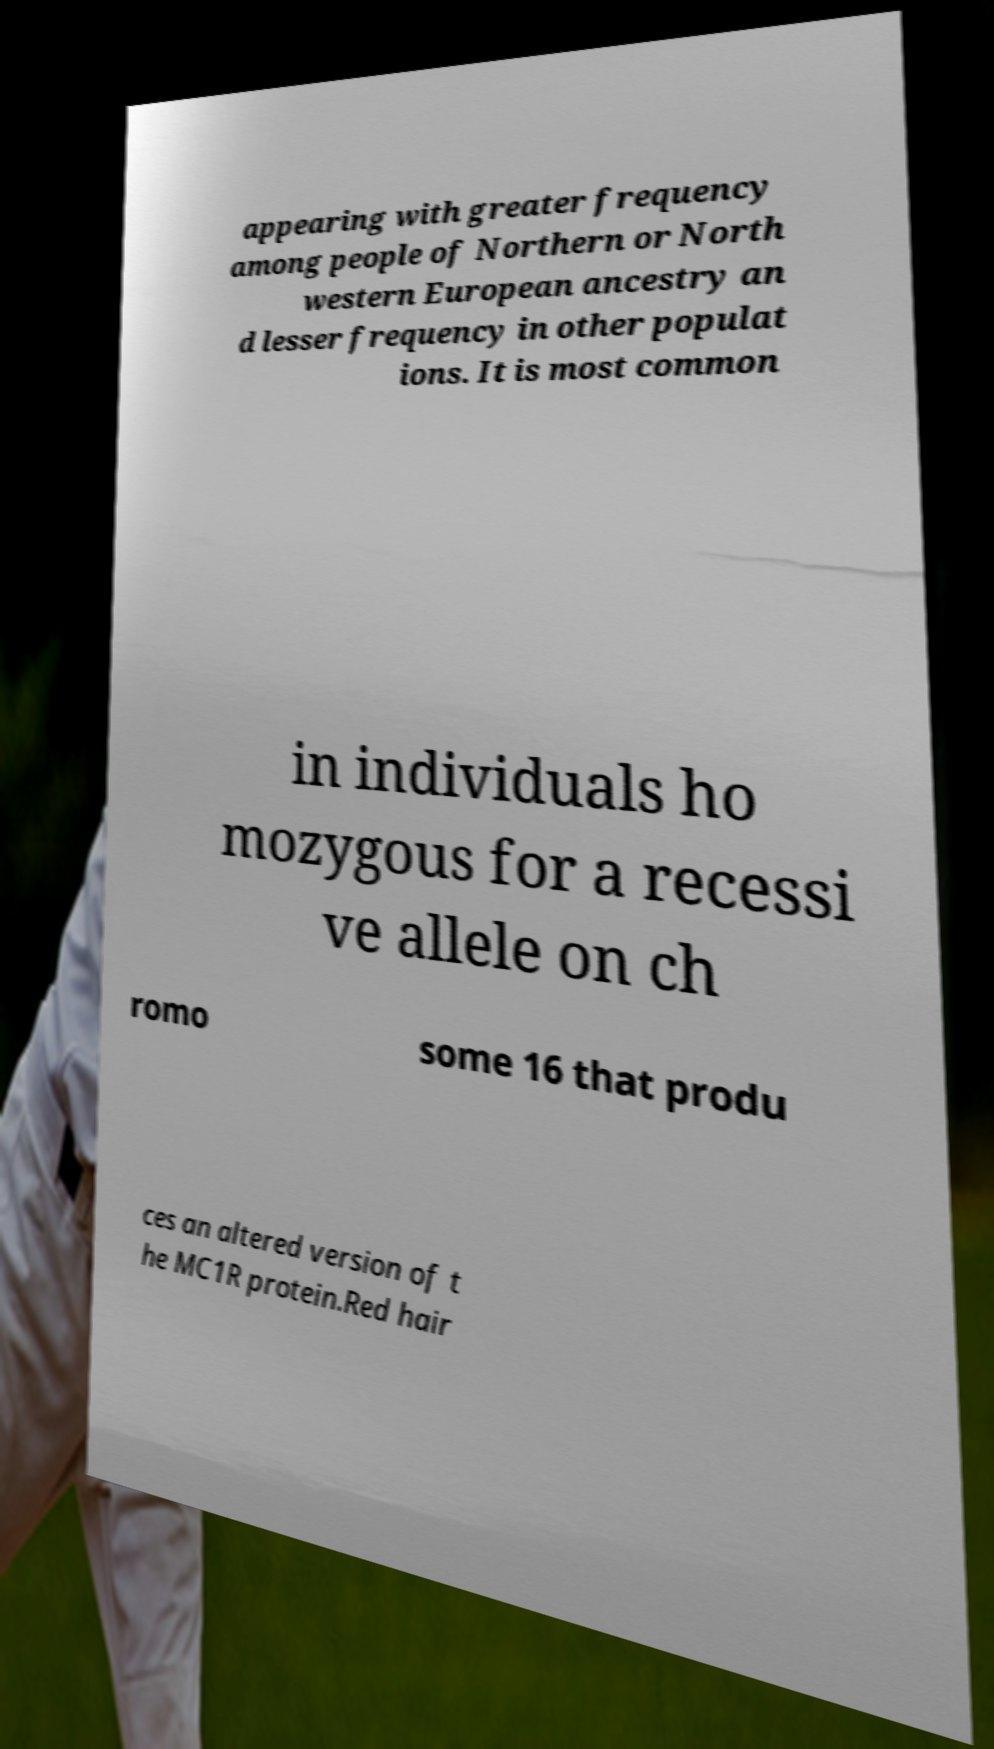Please identify and transcribe the text found in this image. appearing with greater frequency among people of Northern or North western European ancestry an d lesser frequency in other populat ions. It is most common in individuals ho mozygous for a recessi ve allele on ch romo some 16 that produ ces an altered version of t he MC1R protein.Red hair 